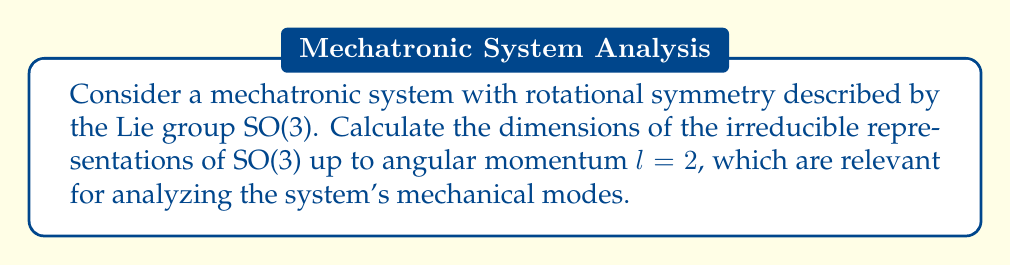Show me your answer to this math problem. To solve this problem, we'll follow these steps:

1) Recall that for SO(3), the irreducible representations are labeled by the angular momentum quantum number $l$, where $l = 0, 1, 2, ...$

2) The dimension of the irreducible representation for a given $l$ is:

   $$\text{dim}(l) = 2l + 1$$

3) Let's calculate the dimensions for $l = 0, 1, 2$:

   For $l = 0$:
   $$\text{dim}(0) = 2(0) + 1 = 1$$

   For $l = 1$:
   $$\text{dim}(1) = 2(1) + 1 = 3$$

   For $l = 2$:
   $$\text{dim}(2) = 2(2) + 1 = 5$$

4) These dimensions correspond to:
   - $l = 0$: Scalar representation (1D)
   - $l = 1$: Vector representation (3D)
   - $l = 2$: Symmetric traceless tensor representation (5D)

5) In the context of a mechatronic system, these representations could correspond to:
   - $l = 0$: Isotropic properties
   - $l = 1$: Directional properties or forces
   - $l = 2$: Quadrupole moments or stress tensors
Answer: 1, 3, 5 